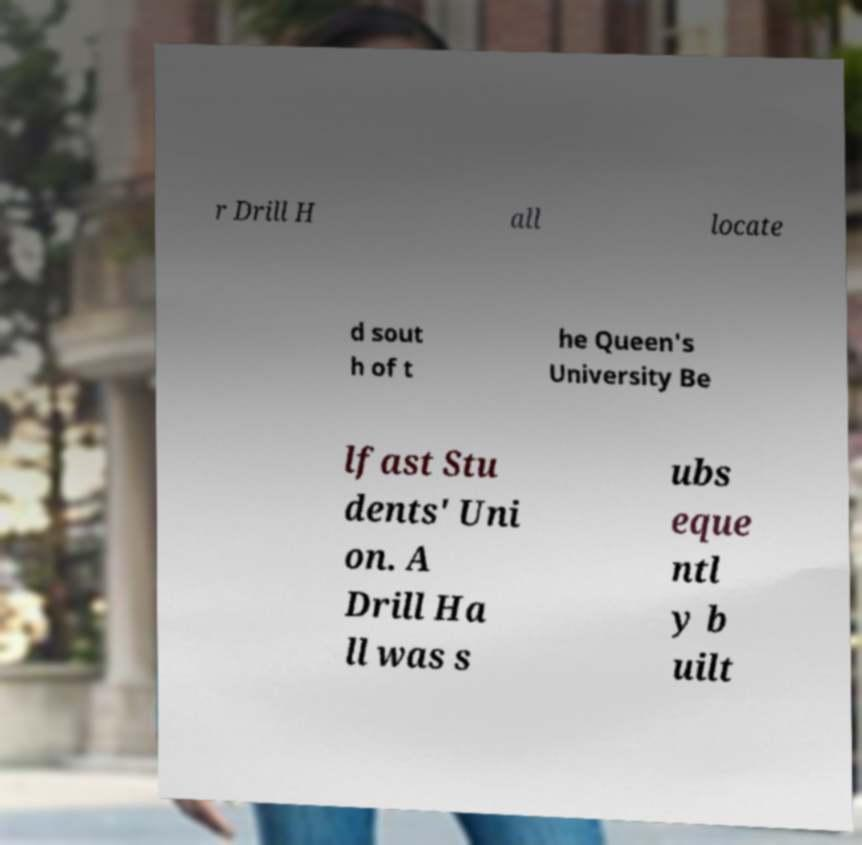Can you accurately transcribe the text from the provided image for me? r Drill H all locate d sout h of t he Queen's University Be lfast Stu dents' Uni on. A Drill Ha ll was s ubs eque ntl y b uilt 